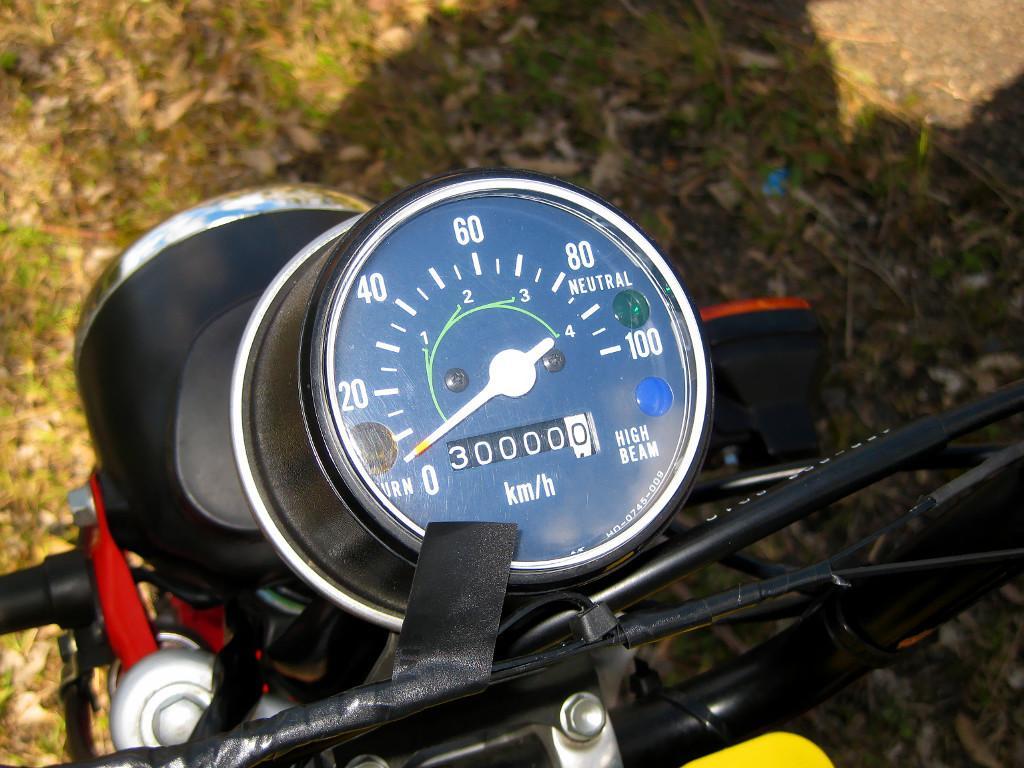Can you describe this image briefly? This picture looks like a motorcycle and I can see odometer and I can see grass on the ground. 